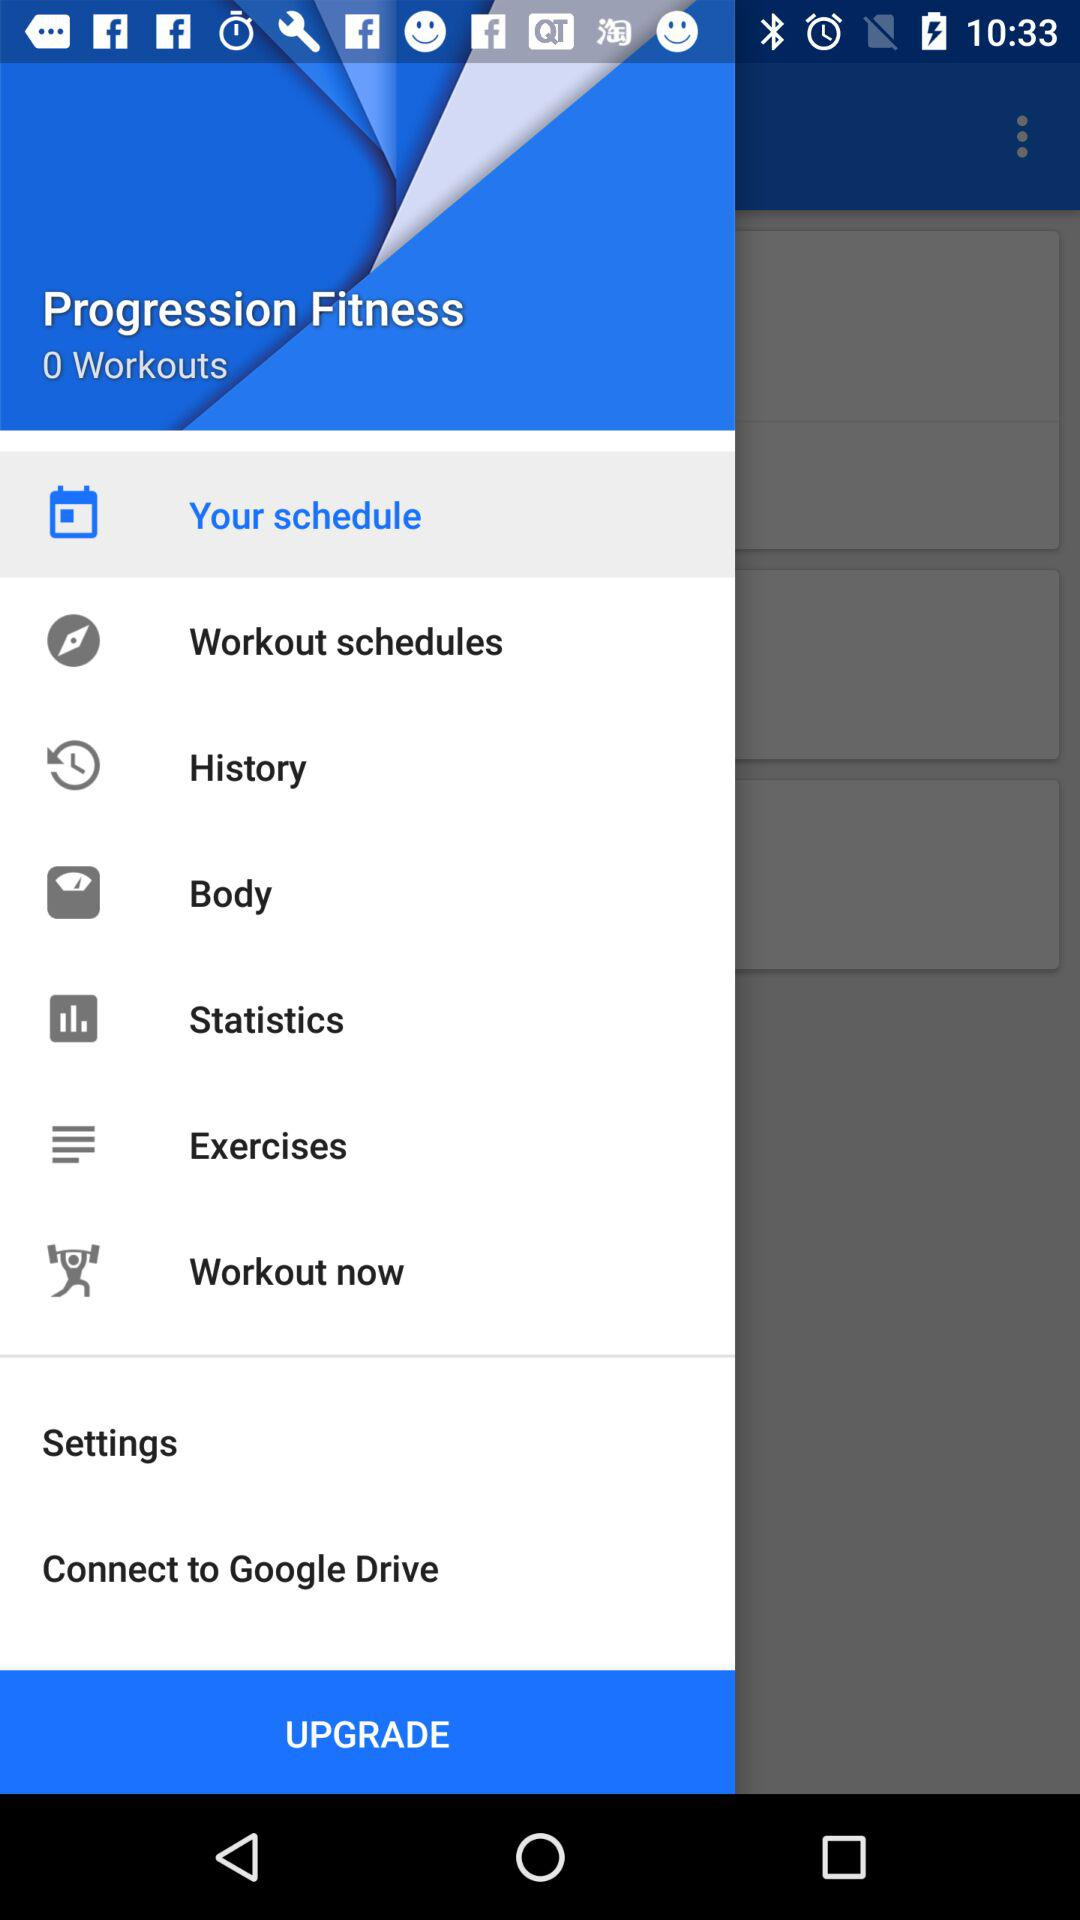What is the application name? The application name is "Progression Fitness". 